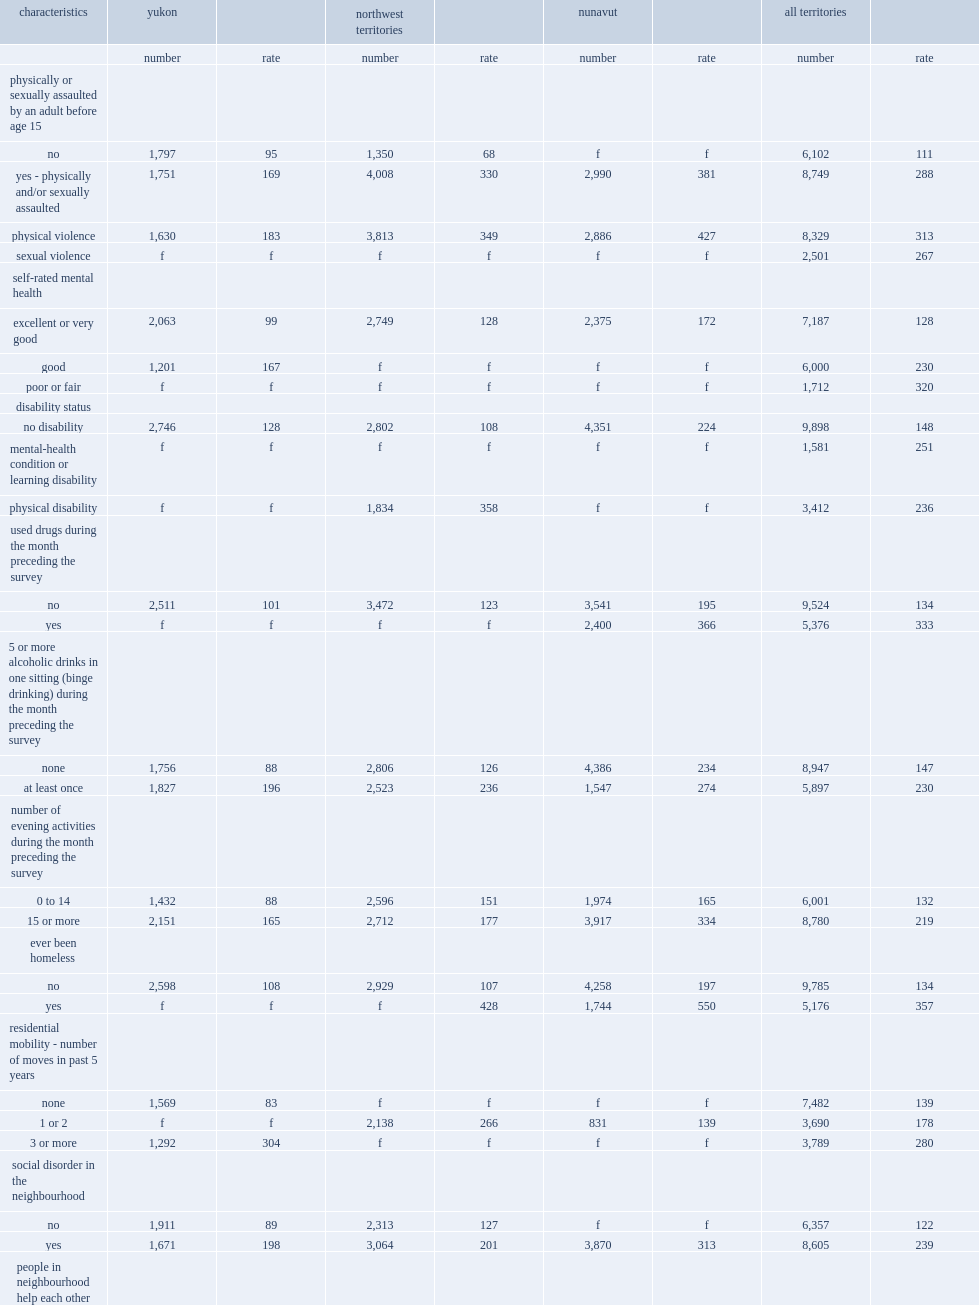What percentage of people of all territories who reported having used drugs in the month preceding the survey? 333.0. What percentage of people of all territories who reported not having used drugs in the month preceding the survey? 134.0. What is the percentage of people who reported having 15 or more evening activities during the month preceding the survey? 219.0. What is the percentage of people who reported not having 15 or more evening activities during the month preceding the survey? 132.0. What is the violent victimization rate of people who reported engaging in at least one binge drinking episode-that is, at least five alcoholic drinks on a single occasion? 230.0. What is the violent victimization rate of people who reported not engaging in binge drinking? 147.0. What is the violent victimization rate of those who reported experiencing childhood maltreatment recorded a violent victimization? 288.0. What is the violent victimization rate of those who reported not experiencing childhood maltreatment recorded a violent victimization? 111.0. What is the violent victimization rate of those who have been homeless or have had to live with family, friends or in a vehicle because they had nowhere else to go? 357.0. What is the violent victimization rate of those who have not been homeless or have not had to live with family, friends or in a vehicle because they had nowhere else to go? 134.0. What is the violent victimization rate of those who stated their neighbourhood was not a place where neighbours helped each other? 291.0. What is the violent victimization rate of those who stated their neighbourhood was a place where neighbours helped each other? 153.0. 